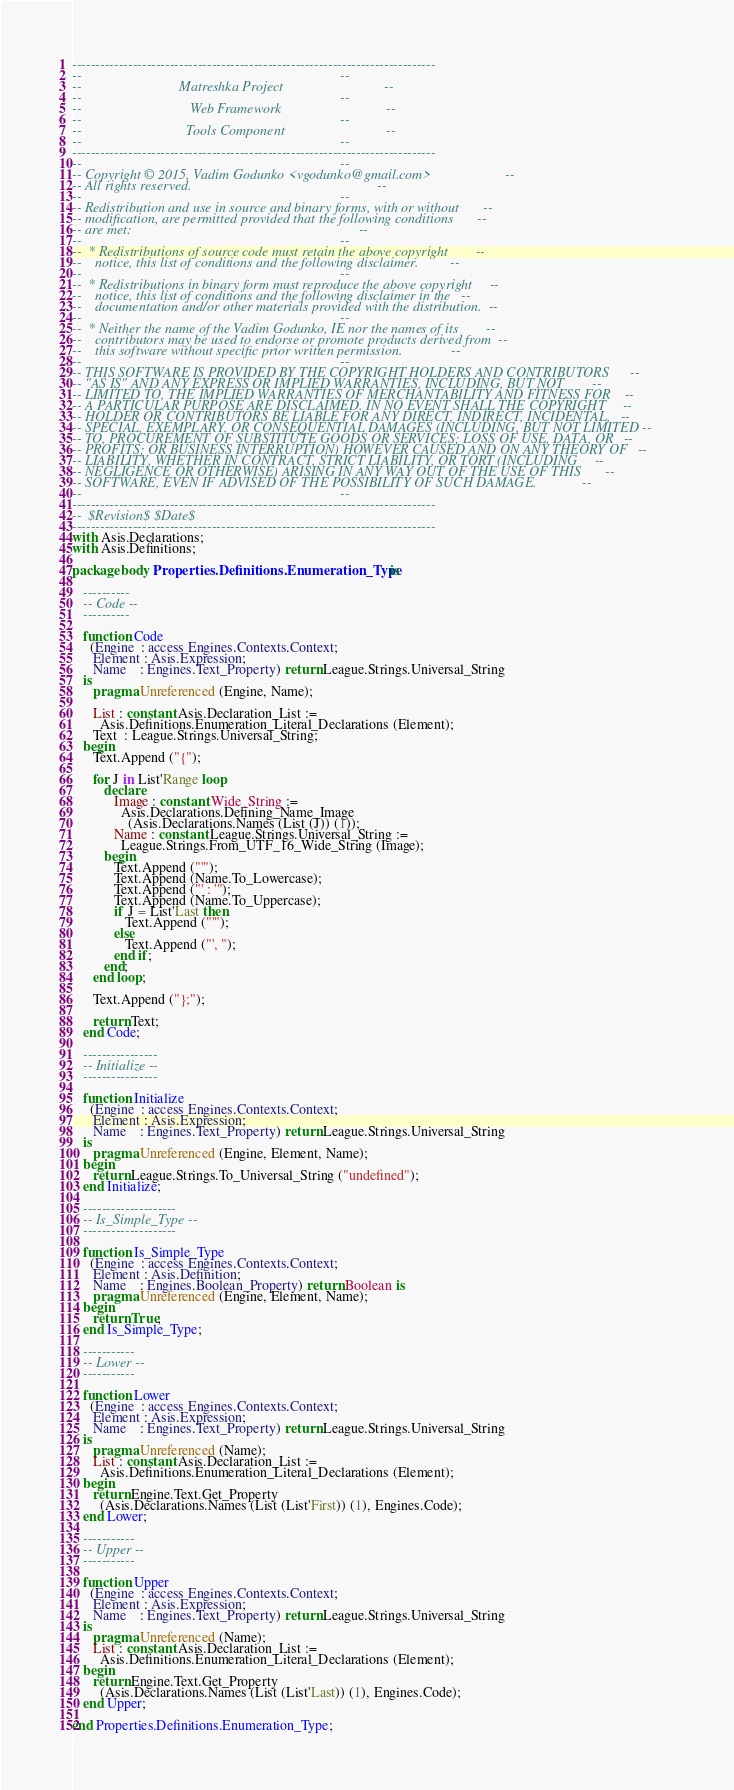Convert code to text. <code><loc_0><loc_0><loc_500><loc_500><_Ada_>------------------------------------------------------------------------------
--                                                                          --
--                            Matreshka Project                             --
--                                                                          --
--                               Web Framework                              --
--                                                                          --
--                              Tools Component                             --
--                                                                          --
------------------------------------------------------------------------------
--                                                                          --
-- Copyright © 2015, Vadim Godunko <vgodunko@gmail.com>                     --
-- All rights reserved.                                                     --
--                                                                          --
-- Redistribution and use in source and binary forms, with or without       --
-- modification, are permitted provided that the following conditions       --
-- are met:                                                                 --
--                                                                          --
--  * Redistributions of source code must retain the above copyright        --
--    notice, this list of conditions and the following disclaimer.         --
--                                                                          --
--  * Redistributions in binary form must reproduce the above copyright     --
--    notice, this list of conditions and the following disclaimer in the   --
--    documentation and/or other materials provided with the distribution.  --
--                                                                          --
--  * Neither the name of the Vadim Godunko, IE nor the names of its        --
--    contributors may be used to endorse or promote products derived from  --
--    this software without specific prior written permission.              --
--                                                                          --
-- THIS SOFTWARE IS PROVIDED BY THE COPYRIGHT HOLDERS AND CONTRIBUTORS      --
-- "AS IS" AND ANY EXPRESS OR IMPLIED WARRANTIES, INCLUDING, BUT NOT        --
-- LIMITED TO, THE IMPLIED WARRANTIES OF MERCHANTABILITY AND FITNESS FOR    --
-- A PARTICULAR PURPOSE ARE DISCLAIMED. IN NO EVENT SHALL THE COPYRIGHT     --
-- HOLDER OR CONTRIBUTORS BE LIABLE FOR ANY DIRECT, INDIRECT, INCIDENTAL,   --
-- SPECIAL, EXEMPLARY, OR CONSEQUENTIAL DAMAGES (INCLUDING, BUT NOT LIMITED --
-- TO, PROCUREMENT OF SUBSTITUTE GOODS OR SERVICES; LOSS OF USE, DATA, OR   --
-- PROFITS; OR BUSINESS INTERRUPTION) HOWEVER CAUSED AND ON ANY THEORY OF   --
-- LIABILITY, WHETHER IN CONTRACT, STRICT LIABILITY, OR TORT (INCLUDING     --
-- NEGLIGENCE OR OTHERWISE) ARISING IN ANY WAY OUT OF THE USE OF THIS       --
-- SOFTWARE, EVEN IF ADVISED OF THE POSSIBILITY OF SUCH DAMAGE.             --
--                                                                          --
------------------------------------------------------------------------------
--  $Revision$ $Date$
------------------------------------------------------------------------------
with Asis.Declarations;
with Asis.Definitions;

package body Properties.Definitions.Enumeration_Type is

   ----------
   -- Code --
   ----------

   function Code
     (Engine  : access Engines.Contexts.Context;
      Element : Asis.Expression;
      Name    : Engines.Text_Property) return League.Strings.Universal_String
   is
      pragma Unreferenced (Engine, Name);

      List : constant Asis.Declaration_List :=
        Asis.Definitions.Enumeration_Literal_Declarations (Element);
      Text  : League.Strings.Universal_String;
   begin
      Text.Append ("{");

      for J in List'Range loop
         declare
            Image : constant Wide_String :=
              Asis.Declarations.Defining_Name_Image
                (Asis.Declarations.Names (List (J)) (1));
            Name : constant League.Strings.Universal_String :=
              League.Strings.From_UTF_16_Wide_String (Image);
         begin
            Text.Append ("'");
            Text.Append (Name.To_Lowercase);
            Text.Append ("' : '");
            Text.Append (Name.To_Uppercase);
            if J = List'Last then
               Text.Append ("'");
            else
               Text.Append ("', ");
            end if;
         end;
      end loop;

      Text.Append ("};");

      return Text;
   end Code;

   ----------------
   -- Initialize --
   ----------------

   function Initialize
     (Engine  : access Engines.Contexts.Context;
      Element : Asis.Expression;
      Name    : Engines.Text_Property) return League.Strings.Universal_String
   is
      pragma Unreferenced (Engine, Element, Name);
   begin
      return League.Strings.To_Universal_String ("undefined");
   end Initialize;

   --------------------
   -- Is_Simple_Type --
   --------------------

   function Is_Simple_Type
     (Engine  : access Engines.Contexts.Context;
      Element : Asis.Definition;
      Name    : Engines.Boolean_Property) return Boolean is
      pragma Unreferenced (Engine, Element, Name);
   begin
      return True;
   end Is_Simple_Type;

   -----------
   -- Lower --
   -----------

   function Lower
     (Engine  : access Engines.Contexts.Context;
      Element : Asis.Expression;
      Name    : Engines.Text_Property) return League.Strings.Universal_String
   is
      pragma Unreferenced (Name);
      List : constant Asis.Declaration_List :=
        Asis.Definitions.Enumeration_Literal_Declarations (Element);
   begin
      return Engine.Text.Get_Property
        (Asis.Declarations.Names (List (List'First)) (1), Engines.Code);
   end Lower;

   -----------
   -- Upper --
   -----------

   function Upper
     (Engine  : access Engines.Contexts.Context;
      Element : Asis.Expression;
      Name    : Engines.Text_Property) return League.Strings.Universal_String
   is
      pragma Unreferenced (Name);
      List : constant Asis.Declaration_List :=
        Asis.Definitions.Enumeration_Literal_Declarations (Element);
   begin
      return Engine.Text.Get_Property
        (Asis.Declarations.Names (List (List'Last)) (1), Engines.Code);
   end Upper;

end Properties.Definitions.Enumeration_Type;
</code> 